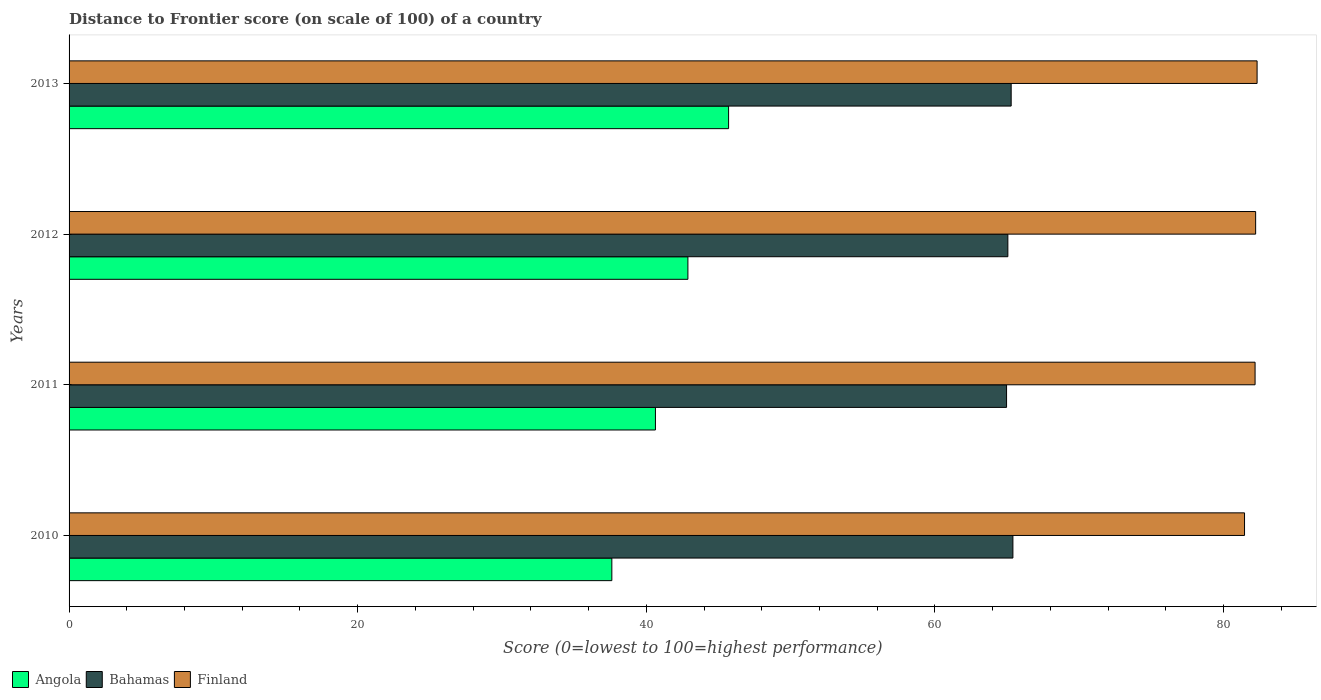How many different coloured bars are there?
Your answer should be compact. 3. What is the distance to frontier score of in Bahamas in 2011?
Make the answer very short. 64.96. Across all years, what is the maximum distance to frontier score of in Finland?
Ensure brevity in your answer.  82.32. Across all years, what is the minimum distance to frontier score of in Bahamas?
Your response must be concise. 64.96. In which year was the distance to frontier score of in Angola minimum?
Give a very brief answer. 2010. What is the total distance to frontier score of in Finland in the graph?
Your answer should be very brief. 328.17. What is the difference between the distance to frontier score of in Angola in 2011 and that in 2013?
Offer a terse response. -5.07. What is the difference between the distance to frontier score of in Finland in 2010 and the distance to frontier score of in Angola in 2013?
Provide a short and direct response. 35.75. What is the average distance to frontier score of in Angola per year?
Keep it short and to the point. 41.7. In the year 2011, what is the difference between the distance to frontier score of in Angola and distance to frontier score of in Bahamas?
Your answer should be very brief. -24.33. In how many years, is the distance to frontier score of in Bahamas greater than 4 ?
Keep it short and to the point. 4. What is the ratio of the distance to frontier score of in Finland in 2010 to that in 2013?
Your answer should be compact. 0.99. Is the distance to frontier score of in Angola in 2011 less than that in 2012?
Your answer should be compact. Yes. Is the difference between the distance to frontier score of in Angola in 2010 and 2013 greater than the difference between the distance to frontier score of in Bahamas in 2010 and 2013?
Offer a very short reply. No. What is the difference between the highest and the second highest distance to frontier score of in Finland?
Offer a very short reply. 0.1. What is the difference between the highest and the lowest distance to frontier score of in Bahamas?
Give a very brief answer. 0.44. In how many years, is the distance to frontier score of in Finland greater than the average distance to frontier score of in Finland taken over all years?
Ensure brevity in your answer.  3. What does the 3rd bar from the top in 2012 represents?
Your answer should be very brief. Angola. Is it the case that in every year, the sum of the distance to frontier score of in Angola and distance to frontier score of in Bahamas is greater than the distance to frontier score of in Finland?
Make the answer very short. Yes. How many bars are there?
Provide a succinct answer. 12. Are all the bars in the graph horizontal?
Provide a succinct answer. Yes. What is the difference between two consecutive major ticks on the X-axis?
Offer a very short reply. 20. Are the values on the major ticks of X-axis written in scientific E-notation?
Offer a very short reply. No. Does the graph contain any zero values?
Your answer should be very brief. No. Where does the legend appear in the graph?
Your answer should be compact. Bottom left. How many legend labels are there?
Provide a succinct answer. 3. What is the title of the graph?
Your answer should be compact. Distance to Frontier score (on scale of 100) of a country. What is the label or title of the X-axis?
Ensure brevity in your answer.  Score (0=lowest to 100=highest performance). What is the label or title of the Y-axis?
Keep it short and to the point. Years. What is the Score (0=lowest to 100=highest performance) of Angola in 2010?
Keep it short and to the point. 37.61. What is the Score (0=lowest to 100=highest performance) of Bahamas in 2010?
Provide a succinct answer. 65.4. What is the Score (0=lowest to 100=highest performance) of Finland in 2010?
Provide a short and direct response. 81.45. What is the Score (0=lowest to 100=highest performance) of Angola in 2011?
Your answer should be compact. 40.63. What is the Score (0=lowest to 100=highest performance) in Bahamas in 2011?
Provide a short and direct response. 64.96. What is the Score (0=lowest to 100=highest performance) in Finland in 2011?
Give a very brief answer. 82.18. What is the Score (0=lowest to 100=highest performance) in Angola in 2012?
Keep it short and to the point. 42.88. What is the Score (0=lowest to 100=highest performance) of Bahamas in 2012?
Offer a terse response. 65.05. What is the Score (0=lowest to 100=highest performance) in Finland in 2012?
Provide a succinct answer. 82.22. What is the Score (0=lowest to 100=highest performance) of Angola in 2013?
Offer a terse response. 45.7. What is the Score (0=lowest to 100=highest performance) in Bahamas in 2013?
Your answer should be compact. 65.28. What is the Score (0=lowest to 100=highest performance) of Finland in 2013?
Keep it short and to the point. 82.32. Across all years, what is the maximum Score (0=lowest to 100=highest performance) of Angola?
Provide a succinct answer. 45.7. Across all years, what is the maximum Score (0=lowest to 100=highest performance) in Bahamas?
Provide a short and direct response. 65.4. Across all years, what is the maximum Score (0=lowest to 100=highest performance) in Finland?
Ensure brevity in your answer.  82.32. Across all years, what is the minimum Score (0=lowest to 100=highest performance) in Angola?
Provide a short and direct response. 37.61. Across all years, what is the minimum Score (0=lowest to 100=highest performance) in Bahamas?
Make the answer very short. 64.96. Across all years, what is the minimum Score (0=lowest to 100=highest performance) in Finland?
Offer a very short reply. 81.45. What is the total Score (0=lowest to 100=highest performance) of Angola in the graph?
Provide a succinct answer. 166.82. What is the total Score (0=lowest to 100=highest performance) in Bahamas in the graph?
Offer a terse response. 260.69. What is the total Score (0=lowest to 100=highest performance) in Finland in the graph?
Your response must be concise. 328.17. What is the difference between the Score (0=lowest to 100=highest performance) of Angola in 2010 and that in 2011?
Provide a succinct answer. -3.02. What is the difference between the Score (0=lowest to 100=highest performance) in Bahamas in 2010 and that in 2011?
Give a very brief answer. 0.44. What is the difference between the Score (0=lowest to 100=highest performance) of Finland in 2010 and that in 2011?
Your answer should be very brief. -0.73. What is the difference between the Score (0=lowest to 100=highest performance) in Angola in 2010 and that in 2012?
Your answer should be compact. -5.27. What is the difference between the Score (0=lowest to 100=highest performance) in Bahamas in 2010 and that in 2012?
Your answer should be very brief. 0.35. What is the difference between the Score (0=lowest to 100=highest performance) of Finland in 2010 and that in 2012?
Make the answer very short. -0.77. What is the difference between the Score (0=lowest to 100=highest performance) of Angola in 2010 and that in 2013?
Your answer should be very brief. -8.09. What is the difference between the Score (0=lowest to 100=highest performance) in Bahamas in 2010 and that in 2013?
Provide a succinct answer. 0.12. What is the difference between the Score (0=lowest to 100=highest performance) in Finland in 2010 and that in 2013?
Keep it short and to the point. -0.87. What is the difference between the Score (0=lowest to 100=highest performance) of Angola in 2011 and that in 2012?
Keep it short and to the point. -2.25. What is the difference between the Score (0=lowest to 100=highest performance) of Bahamas in 2011 and that in 2012?
Offer a very short reply. -0.09. What is the difference between the Score (0=lowest to 100=highest performance) of Finland in 2011 and that in 2012?
Make the answer very short. -0.04. What is the difference between the Score (0=lowest to 100=highest performance) in Angola in 2011 and that in 2013?
Make the answer very short. -5.07. What is the difference between the Score (0=lowest to 100=highest performance) of Bahamas in 2011 and that in 2013?
Make the answer very short. -0.32. What is the difference between the Score (0=lowest to 100=highest performance) in Finland in 2011 and that in 2013?
Make the answer very short. -0.14. What is the difference between the Score (0=lowest to 100=highest performance) of Angola in 2012 and that in 2013?
Offer a terse response. -2.82. What is the difference between the Score (0=lowest to 100=highest performance) of Bahamas in 2012 and that in 2013?
Keep it short and to the point. -0.23. What is the difference between the Score (0=lowest to 100=highest performance) in Angola in 2010 and the Score (0=lowest to 100=highest performance) in Bahamas in 2011?
Offer a very short reply. -27.35. What is the difference between the Score (0=lowest to 100=highest performance) of Angola in 2010 and the Score (0=lowest to 100=highest performance) of Finland in 2011?
Provide a succinct answer. -44.57. What is the difference between the Score (0=lowest to 100=highest performance) of Bahamas in 2010 and the Score (0=lowest to 100=highest performance) of Finland in 2011?
Keep it short and to the point. -16.78. What is the difference between the Score (0=lowest to 100=highest performance) in Angola in 2010 and the Score (0=lowest to 100=highest performance) in Bahamas in 2012?
Keep it short and to the point. -27.44. What is the difference between the Score (0=lowest to 100=highest performance) of Angola in 2010 and the Score (0=lowest to 100=highest performance) of Finland in 2012?
Your answer should be very brief. -44.61. What is the difference between the Score (0=lowest to 100=highest performance) in Bahamas in 2010 and the Score (0=lowest to 100=highest performance) in Finland in 2012?
Keep it short and to the point. -16.82. What is the difference between the Score (0=lowest to 100=highest performance) in Angola in 2010 and the Score (0=lowest to 100=highest performance) in Bahamas in 2013?
Provide a succinct answer. -27.67. What is the difference between the Score (0=lowest to 100=highest performance) in Angola in 2010 and the Score (0=lowest to 100=highest performance) in Finland in 2013?
Offer a terse response. -44.71. What is the difference between the Score (0=lowest to 100=highest performance) in Bahamas in 2010 and the Score (0=lowest to 100=highest performance) in Finland in 2013?
Give a very brief answer. -16.92. What is the difference between the Score (0=lowest to 100=highest performance) in Angola in 2011 and the Score (0=lowest to 100=highest performance) in Bahamas in 2012?
Your answer should be compact. -24.42. What is the difference between the Score (0=lowest to 100=highest performance) in Angola in 2011 and the Score (0=lowest to 100=highest performance) in Finland in 2012?
Provide a succinct answer. -41.59. What is the difference between the Score (0=lowest to 100=highest performance) of Bahamas in 2011 and the Score (0=lowest to 100=highest performance) of Finland in 2012?
Your answer should be compact. -17.26. What is the difference between the Score (0=lowest to 100=highest performance) of Angola in 2011 and the Score (0=lowest to 100=highest performance) of Bahamas in 2013?
Your response must be concise. -24.65. What is the difference between the Score (0=lowest to 100=highest performance) in Angola in 2011 and the Score (0=lowest to 100=highest performance) in Finland in 2013?
Offer a terse response. -41.69. What is the difference between the Score (0=lowest to 100=highest performance) of Bahamas in 2011 and the Score (0=lowest to 100=highest performance) of Finland in 2013?
Provide a succinct answer. -17.36. What is the difference between the Score (0=lowest to 100=highest performance) in Angola in 2012 and the Score (0=lowest to 100=highest performance) in Bahamas in 2013?
Offer a terse response. -22.4. What is the difference between the Score (0=lowest to 100=highest performance) of Angola in 2012 and the Score (0=lowest to 100=highest performance) of Finland in 2013?
Provide a succinct answer. -39.44. What is the difference between the Score (0=lowest to 100=highest performance) of Bahamas in 2012 and the Score (0=lowest to 100=highest performance) of Finland in 2013?
Ensure brevity in your answer.  -17.27. What is the average Score (0=lowest to 100=highest performance) of Angola per year?
Make the answer very short. 41.7. What is the average Score (0=lowest to 100=highest performance) of Bahamas per year?
Offer a very short reply. 65.17. What is the average Score (0=lowest to 100=highest performance) in Finland per year?
Provide a short and direct response. 82.04. In the year 2010, what is the difference between the Score (0=lowest to 100=highest performance) in Angola and Score (0=lowest to 100=highest performance) in Bahamas?
Make the answer very short. -27.79. In the year 2010, what is the difference between the Score (0=lowest to 100=highest performance) of Angola and Score (0=lowest to 100=highest performance) of Finland?
Provide a short and direct response. -43.84. In the year 2010, what is the difference between the Score (0=lowest to 100=highest performance) of Bahamas and Score (0=lowest to 100=highest performance) of Finland?
Your answer should be compact. -16.05. In the year 2011, what is the difference between the Score (0=lowest to 100=highest performance) in Angola and Score (0=lowest to 100=highest performance) in Bahamas?
Offer a very short reply. -24.33. In the year 2011, what is the difference between the Score (0=lowest to 100=highest performance) of Angola and Score (0=lowest to 100=highest performance) of Finland?
Keep it short and to the point. -41.55. In the year 2011, what is the difference between the Score (0=lowest to 100=highest performance) in Bahamas and Score (0=lowest to 100=highest performance) in Finland?
Offer a very short reply. -17.22. In the year 2012, what is the difference between the Score (0=lowest to 100=highest performance) in Angola and Score (0=lowest to 100=highest performance) in Bahamas?
Ensure brevity in your answer.  -22.17. In the year 2012, what is the difference between the Score (0=lowest to 100=highest performance) of Angola and Score (0=lowest to 100=highest performance) of Finland?
Offer a terse response. -39.34. In the year 2012, what is the difference between the Score (0=lowest to 100=highest performance) of Bahamas and Score (0=lowest to 100=highest performance) of Finland?
Provide a short and direct response. -17.17. In the year 2013, what is the difference between the Score (0=lowest to 100=highest performance) of Angola and Score (0=lowest to 100=highest performance) of Bahamas?
Provide a short and direct response. -19.58. In the year 2013, what is the difference between the Score (0=lowest to 100=highest performance) of Angola and Score (0=lowest to 100=highest performance) of Finland?
Keep it short and to the point. -36.62. In the year 2013, what is the difference between the Score (0=lowest to 100=highest performance) in Bahamas and Score (0=lowest to 100=highest performance) in Finland?
Offer a terse response. -17.04. What is the ratio of the Score (0=lowest to 100=highest performance) in Angola in 2010 to that in 2011?
Your response must be concise. 0.93. What is the ratio of the Score (0=lowest to 100=highest performance) of Bahamas in 2010 to that in 2011?
Give a very brief answer. 1.01. What is the ratio of the Score (0=lowest to 100=highest performance) of Finland in 2010 to that in 2011?
Make the answer very short. 0.99. What is the ratio of the Score (0=lowest to 100=highest performance) of Angola in 2010 to that in 2012?
Make the answer very short. 0.88. What is the ratio of the Score (0=lowest to 100=highest performance) in Bahamas in 2010 to that in 2012?
Your answer should be compact. 1.01. What is the ratio of the Score (0=lowest to 100=highest performance) of Finland in 2010 to that in 2012?
Provide a succinct answer. 0.99. What is the ratio of the Score (0=lowest to 100=highest performance) in Angola in 2010 to that in 2013?
Your answer should be compact. 0.82. What is the ratio of the Score (0=lowest to 100=highest performance) of Bahamas in 2010 to that in 2013?
Offer a very short reply. 1. What is the ratio of the Score (0=lowest to 100=highest performance) in Finland in 2010 to that in 2013?
Your answer should be compact. 0.99. What is the ratio of the Score (0=lowest to 100=highest performance) of Angola in 2011 to that in 2012?
Provide a succinct answer. 0.95. What is the ratio of the Score (0=lowest to 100=highest performance) of Bahamas in 2011 to that in 2012?
Your answer should be very brief. 1. What is the ratio of the Score (0=lowest to 100=highest performance) in Angola in 2011 to that in 2013?
Your response must be concise. 0.89. What is the ratio of the Score (0=lowest to 100=highest performance) in Finland in 2011 to that in 2013?
Offer a very short reply. 1. What is the ratio of the Score (0=lowest to 100=highest performance) in Angola in 2012 to that in 2013?
Your response must be concise. 0.94. What is the ratio of the Score (0=lowest to 100=highest performance) of Bahamas in 2012 to that in 2013?
Provide a succinct answer. 1. What is the difference between the highest and the second highest Score (0=lowest to 100=highest performance) in Angola?
Your response must be concise. 2.82. What is the difference between the highest and the second highest Score (0=lowest to 100=highest performance) in Bahamas?
Ensure brevity in your answer.  0.12. What is the difference between the highest and the lowest Score (0=lowest to 100=highest performance) of Angola?
Your answer should be very brief. 8.09. What is the difference between the highest and the lowest Score (0=lowest to 100=highest performance) in Bahamas?
Your answer should be very brief. 0.44. What is the difference between the highest and the lowest Score (0=lowest to 100=highest performance) in Finland?
Offer a terse response. 0.87. 